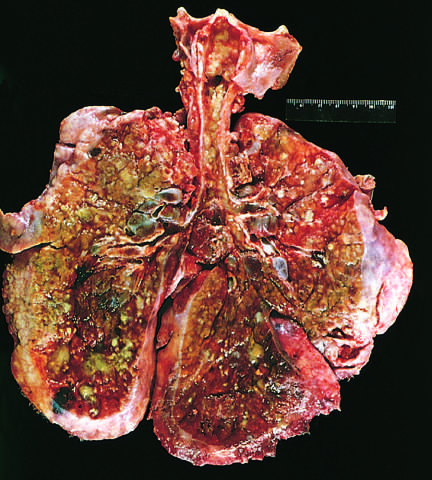s collagen the product of pseudomonas infections?
Answer the question using a single word or phrase. No 